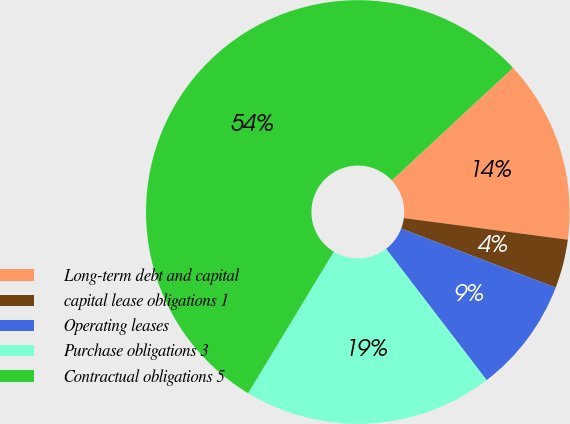<chart> <loc_0><loc_0><loc_500><loc_500><pie_chart><fcel>Long-term debt and capital<fcel>capital lease obligations 1<fcel>Operating leases<fcel>Purchase obligations 3<fcel>Contractual obligations 5<nl><fcel>14.0%<fcel>3.72%<fcel>8.79%<fcel>19.07%<fcel>54.42%<nl></chart> 